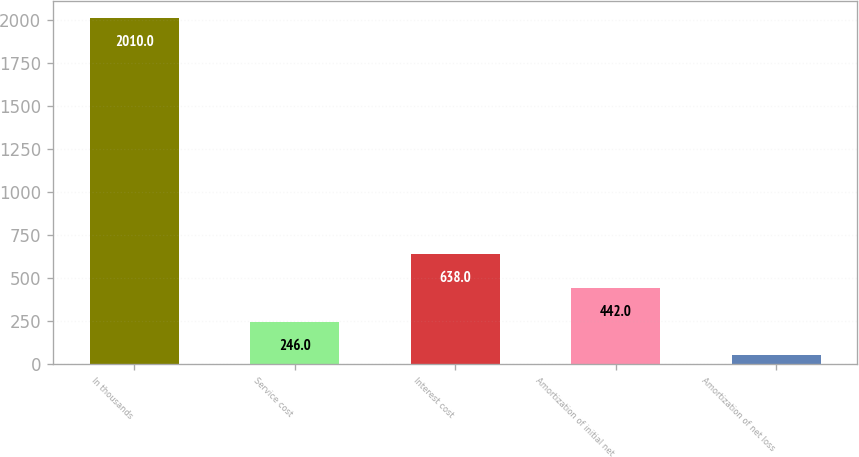Convert chart. <chart><loc_0><loc_0><loc_500><loc_500><bar_chart><fcel>In thousands<fcel>Service cost<fcel>Interest cost<fcel>Amortization of initial net<fcel>Amortization of net loss<nl><fcel>2010<fcel>246<fcel>638<fcel>442<fcel>50<nl></chart> 